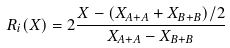<formula> <loc_0><loc_0><loc_500><loc_500>R _ { i } ( X ) = 2 \frac { X - ( X _ { A + A } + X _ { B + B } ) / 2 } { X _ { A + A } - X _ { B + B } }</formula> 